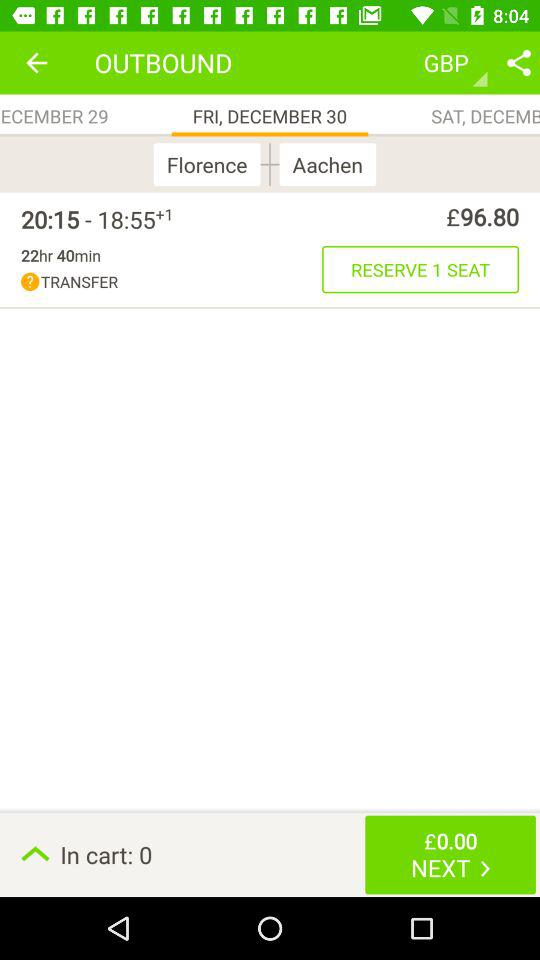How much does it cost for 1 seat? It costs £96.80 for 1 seat. 